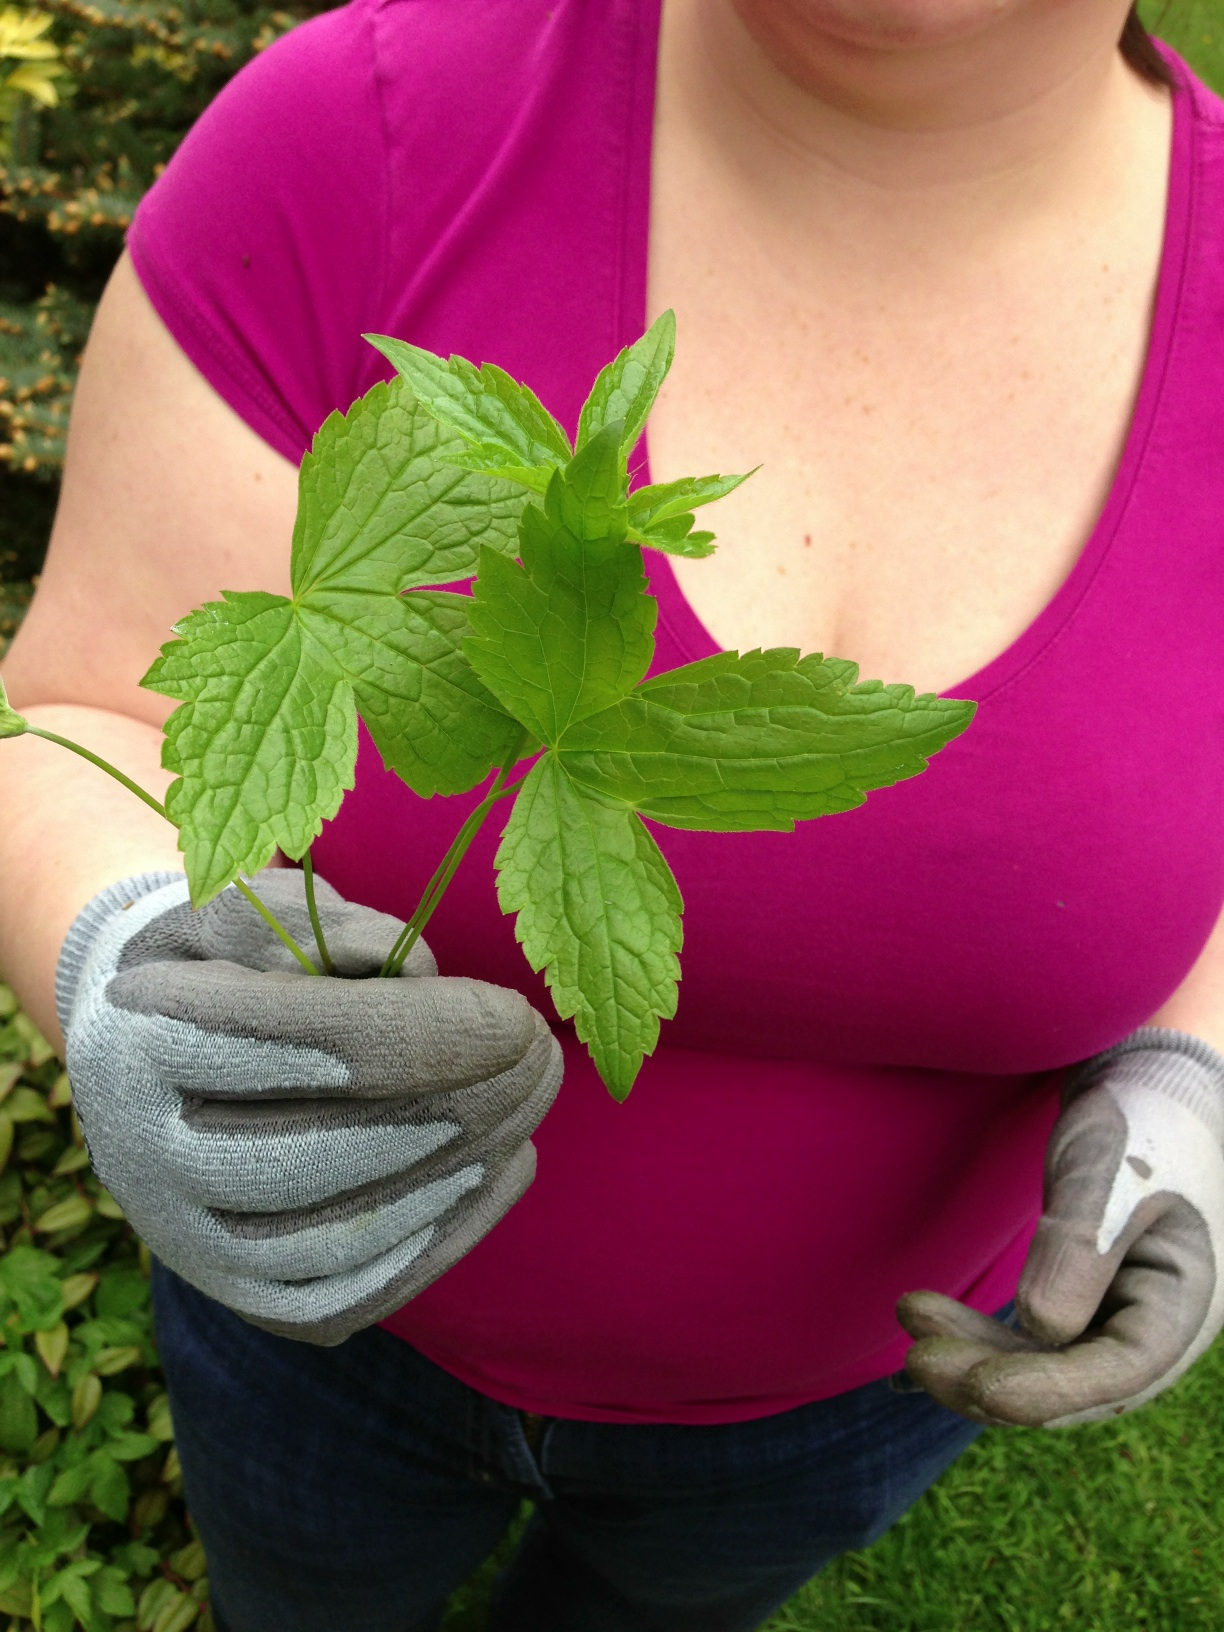Could this plant be toxic to pets or humans? It's important to identify the plant accurately before determining its safety. Many plants with similar features can be toxic. I advise consulting a local botanist or using a plant identification app to ensure safe handling. 